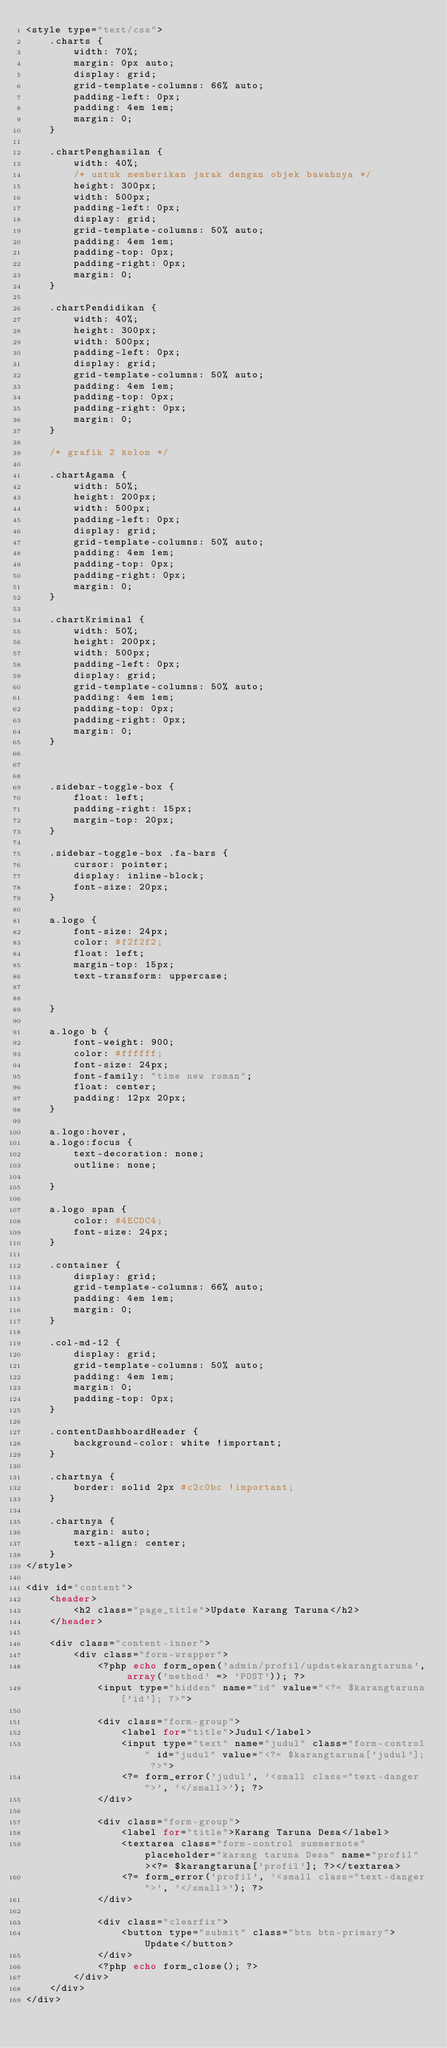<code> <loc_0><loc_0><loc_500><loc_500><_PHP_><style type="text/css">
    .charts {
        width: 70%;
        margin: 0px auto;
        display: grid;
        grid-template-columns: 66% auto;
        padding-left: 0px;
        padding: 4em 1em;
        margin: 0;
    }

    .chartPenghasilan {
        width: 40%;
        /* untuk memberikan jarak dengan objek bawahnya */
        height: 300px;
        width: 500px;
        padding-left: 0px;
        display: grid;
        grid-template-columns: 50% auto;
        padding: 4em 1em;
        padding-top: 0px;
        padding-right: 0px;
        margin: 0;
    }

    .chartPendidikan {
        width: 40%;
        height: 300px;
        width: 500px;
        padding-left: 0px;
        display: grid;
        grid-template-columns: 50% auto;
        padding: 4em 1em;
        padding-top: 0px;
        padding-right: 0px;
        margin: 0;
    }

    /* grafik 2 kolom */

    .chartAgama {
        width: 50%;
        height: 200px;
        width: 500px;
        padding-left: 0px;
        display: grid;
        grid-template-columns: 50% auto;
        padding: 4em 1em;
        padding-top: 0px;
        padding-right: 0px;
        margin: 0;
    }

    .chartKriminal {
        width: 50%;
        height: 200px;
        width: 500px;
        padding-left: 0px;
        display: grid;
        grid-template-columns: 50% auto;
        padding: 4em 1em;
        padding-top: 0px;
        padding-right: 0px;
        margin: 0;
    }



    .sidebar-toggle-box {
        float: left;
        padding-right: 15px;
        margin-top: 20px;
    }

    .sidebar-toggle-box .fa-bars {
        cursor: pointer;
        display: inline-block;
        font-size: 20px;
    }

    a.logo {
        font-size: 24px;
        color: #f2f2f2;
        float: left;
        margin-top: 15px;
        text-transform: uppercase;
        

    }

    a.logo b {
        font-weight: 900;
        color: #ffffff;
        font-size: 24px;
        font-family: "time new roman";
        float: center;
        padding: 12px 20px;
    }

    a.logo:hover,
    a.logo:focus {
        text-decoration: none;
        outline: none;

    }

    a.logo span {
        color: #4ECDC4;
        font-size: 24px;
    }

    .container {
        display: grid;
        grid-template-columns: 66% auto;
        padding: 4em 1em;
        margin: 0;
    }

    .col-md-12 {
        display: grid;
        grid-template-columns: 50% auto;
        padding: 4em 1em;
        margin: 0;
        padding-top: 0px;
    }

    .contentDashboardHeader {
        background-color: white !important;
    }

    .chartnya {
        border: solid 2px #c2c0bc !important;
    }

    .chartnya {
        margin: auto;
        text-align: center;
    }
</style>

<div id="content">
    <header>
        <h2 class="page_title">Update Karang Taruna</h2>
    </header>

    <div class="content-inner">
        <div class="form-wrapper">
            <?php echo form_open('admin/profil/updatekarangtaruna', array('method' => 'POST')); ?>
            <input type="hidden" name="id" value="<?= $karangtaruna['id']; ?>">

            <div class="form-group">
                <label for="title">Judul</label>
                <input type="text" name="judul" class="form-control" id="judul" value="<?= $karangtaruna['judul']; ?>">
                <?= form_error('judul', '<small class="text-danger">', '</small>'); ?>
            </div>

            <div class="form-group">
                <label for="title">Karang Taruna Desa</label>
                <textarea class="form-control summernote" placeholder="karang taruna Desa" name="profil"><?= $karangtaruna['profil']; ?></textarea>
                <?= form_error('profil', '<small class="text-danger">', '</small>'); ?>
            </div>

            <div class="clearfix">
                <button type="submit" class="btn btn-primary">Update</button>
            </div>
            <?php echo form_close(); ?>
        </div>
    </div>
</div></code> 